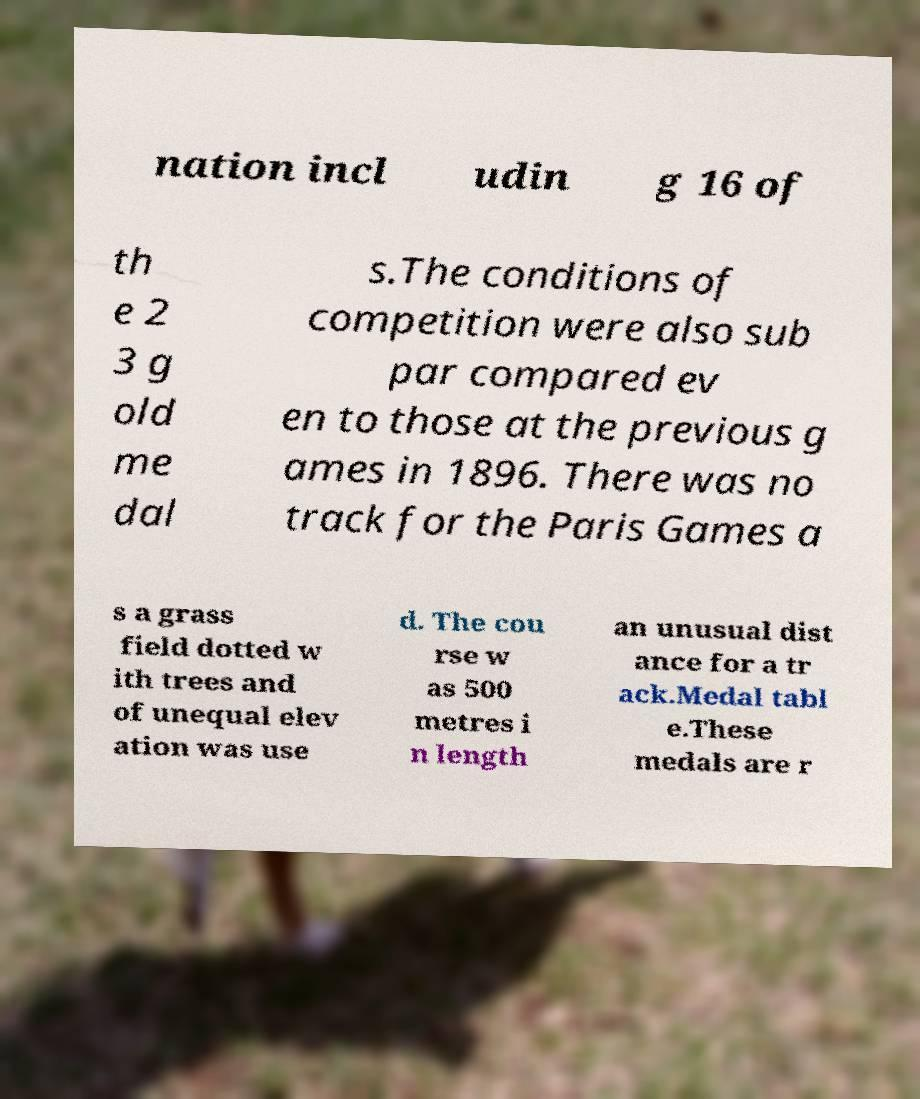Please read and relay the text visible in this image. What does it say? nation incl udin g 16 of th e 2 3 g old me dal s.The conditions of competition were also sub par compared ev en to those at the previous g ames in 1896. There was no track for the Paris Games a s a grass field dotted w ith trees and of unequal elev ation was use d. The cou rse w as 500 metres i n length an unusual dist ance for a tr ack.Medal tabl e.These medals are r 